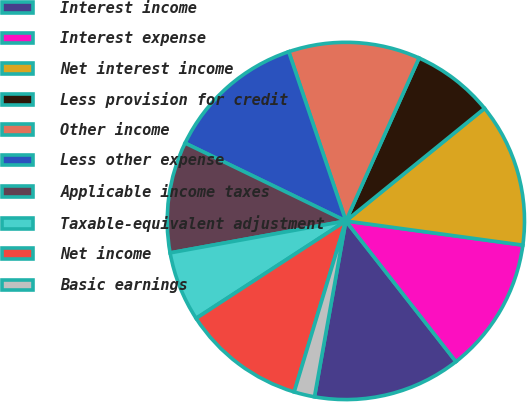Convert chart to OTSL. <chart><loc_0><loc_0><loc_500><loc_500><pie_chart><fcel>Interest income<fcel>Interest expense<fcel>Net interest income<fcel>Less provision for credit<fcel>Other income<fcel>Less other expense<fcel>Applicable income taxes<fcel>Taxable-equivalent adjustment<fcel>Net income<fcel>Basic earnings<nl><fcel>13.38%<fcel>12.27%<fcel>13.01%<fcel>7.43%<fcel>11.9%<fcel>12.64%<fcel>10.04%<fcel>6.32%<fcel>11.15%<fcel>1.86%<nl></chart> 